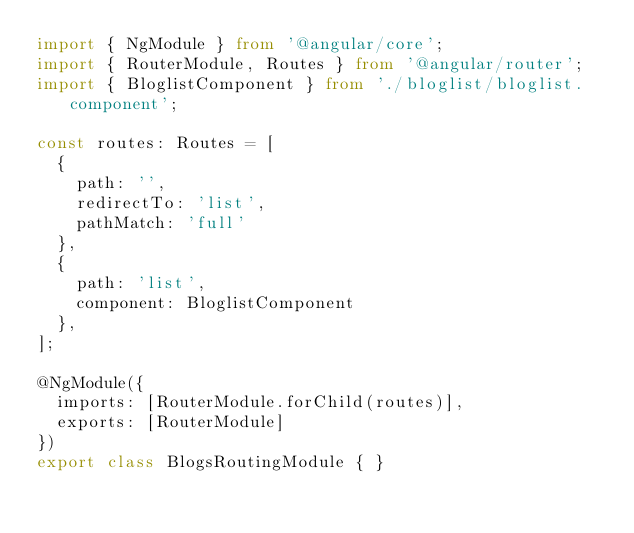<code> <loc_0><loc_0><loc_500><loc_500><_TypeScript_>import { NgModule } from '@angular/core';
import { RouterModule, Routes } from '@angular/router';
import { BloglistComponent } from './bloglist/bloglist.component';

const routes: Routes = [
  {
    path: '',
    redirectTo: 'list',
    pathMatch: 'full'
  },
  {
    path: 'list',
    component: BloglistComponent
  },
];

@NgModule({
  imports: [RouterModule.forChild(routes)],
  exports: [RouterModule]
})
export class BlogsRoutingModule { }
</code> 